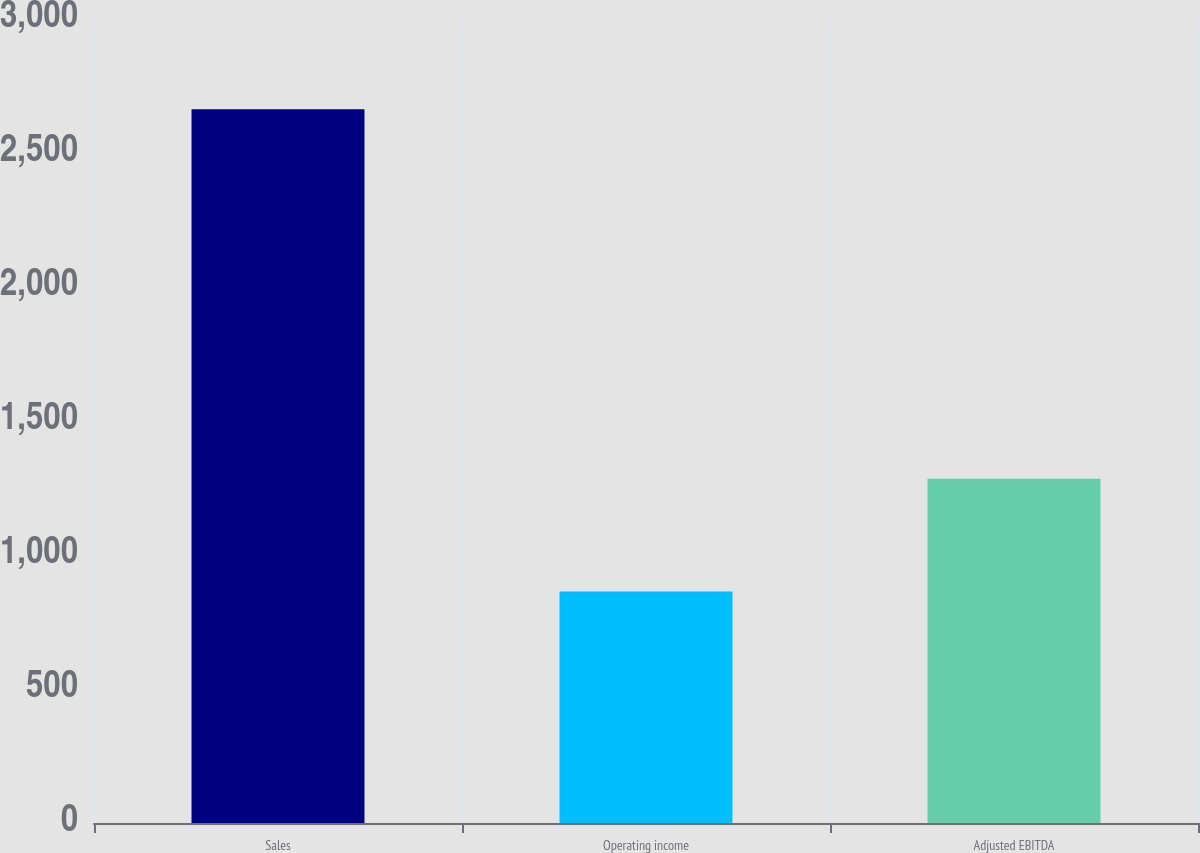<chart> <loc_0><loc_0><loc_500><loc_500><bar_chart><fcel>Sales<fcel>Operating income<fcel>Adjusted EBITDA<nl><fcel>2663.6<fcel>864.2<fcel>1284.1<nl></chart> 